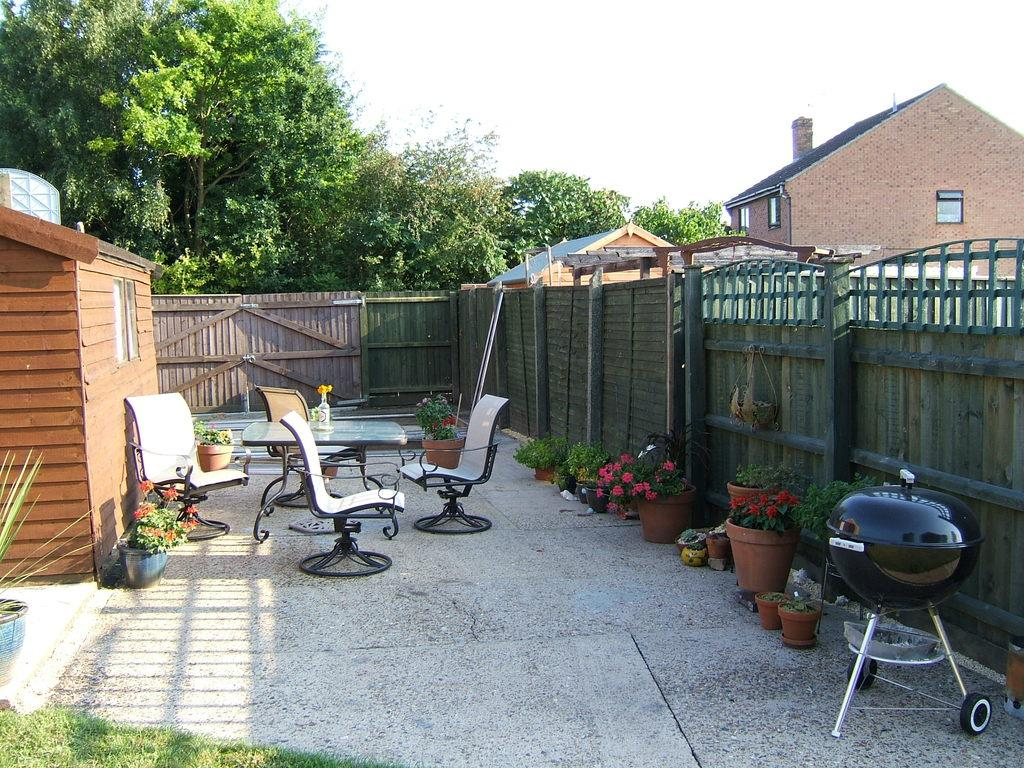What type of furniture is present in the image? There are chairs in the image. What is the primary piece of furniture in the image? There is a table in the image. What type of greenery can be seen in the image? There are plants and trees in the image. What type of structure is visible in the image? There is a house in the image. What architectural feature is present in the image? There is a window in the image. What part of the natural environment is visible in the image? The sky is visible in the image. What type of list can be seen hanging on the wall in the image? There is no list present in the image. How many sheep are visible in the image? There are no sheep present in the image. 